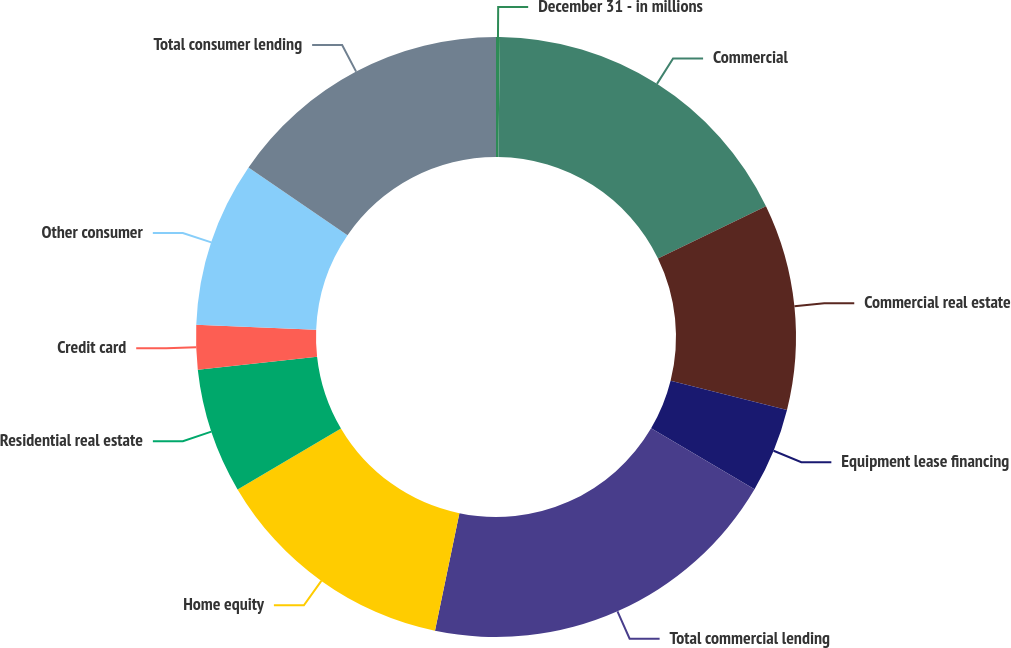Convert chart to OTSL. <chart><loc_0><loc_0><loc_500><loc_500><pie_chart><fcel>December 31 - in millions<fcel>Commercial<fcel>Commercial real estate<fcel>Equipment lease financing<fcel>Total commercial lending<fcel>Home equity<fcel>Residential real estate<fcel>Credit card<fcel>Other consumer<fcel>Total consumer lending<nl><fcel>0.21%<fcel>17.61%<fcel>11.09%<fcel>4.56%<fcel>19.79%<fcel>13.26%<fcel>6.74%<fcel>2.39%<fcel>8.91%<fcel>15.44%<nl></chart> 